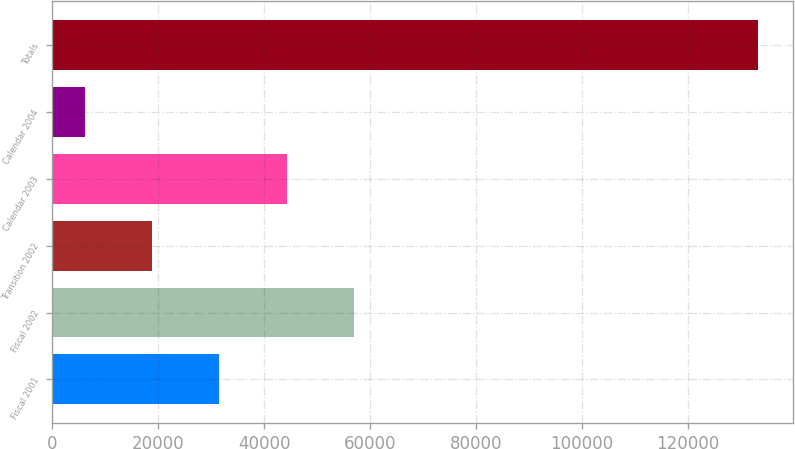Convert chart to OTSL. <chart><loc_0><loc_0><loc_500><loc_500><bar_chart><fcel>Fiscal 2001<fcel>Fiscal 2002<fcel>Transition 2002<fcel>Calendar 2003<fcel>Calendar 2004<fcel>Totals<nl><fcel>31538.6<fcel>56965.2<fcel>18825.3<fcel>44251.9<fcel>6112<fcel>133245<nl></chart> 